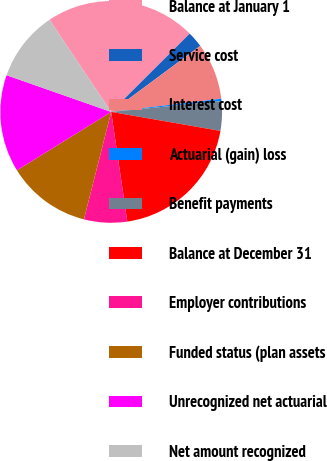Convert chart. <chart><loc_0><loc_0><loc_500><loc_500><pie_chart><fcel>Balance at January 1<fcel>Service cost<fcel>Interest cost<fcel>Actuarial (gain) loss<fcel>Benefit payments<fcel>Balance at December 31<fcel>Employer contributions<fcel>Funded status (plan assets<fcel>Unrecognized net actuarial<fcel>Net amount recognized<nl><fcel>21.92%<fcel>2.32%<fcel>8.26%<fcel>0.34%<fcel>4.3%<fcel>19.94%<fcel>6.28%<fcel>12.22%<fcel>14.2%<fcel>10.24%<nl></chart> 